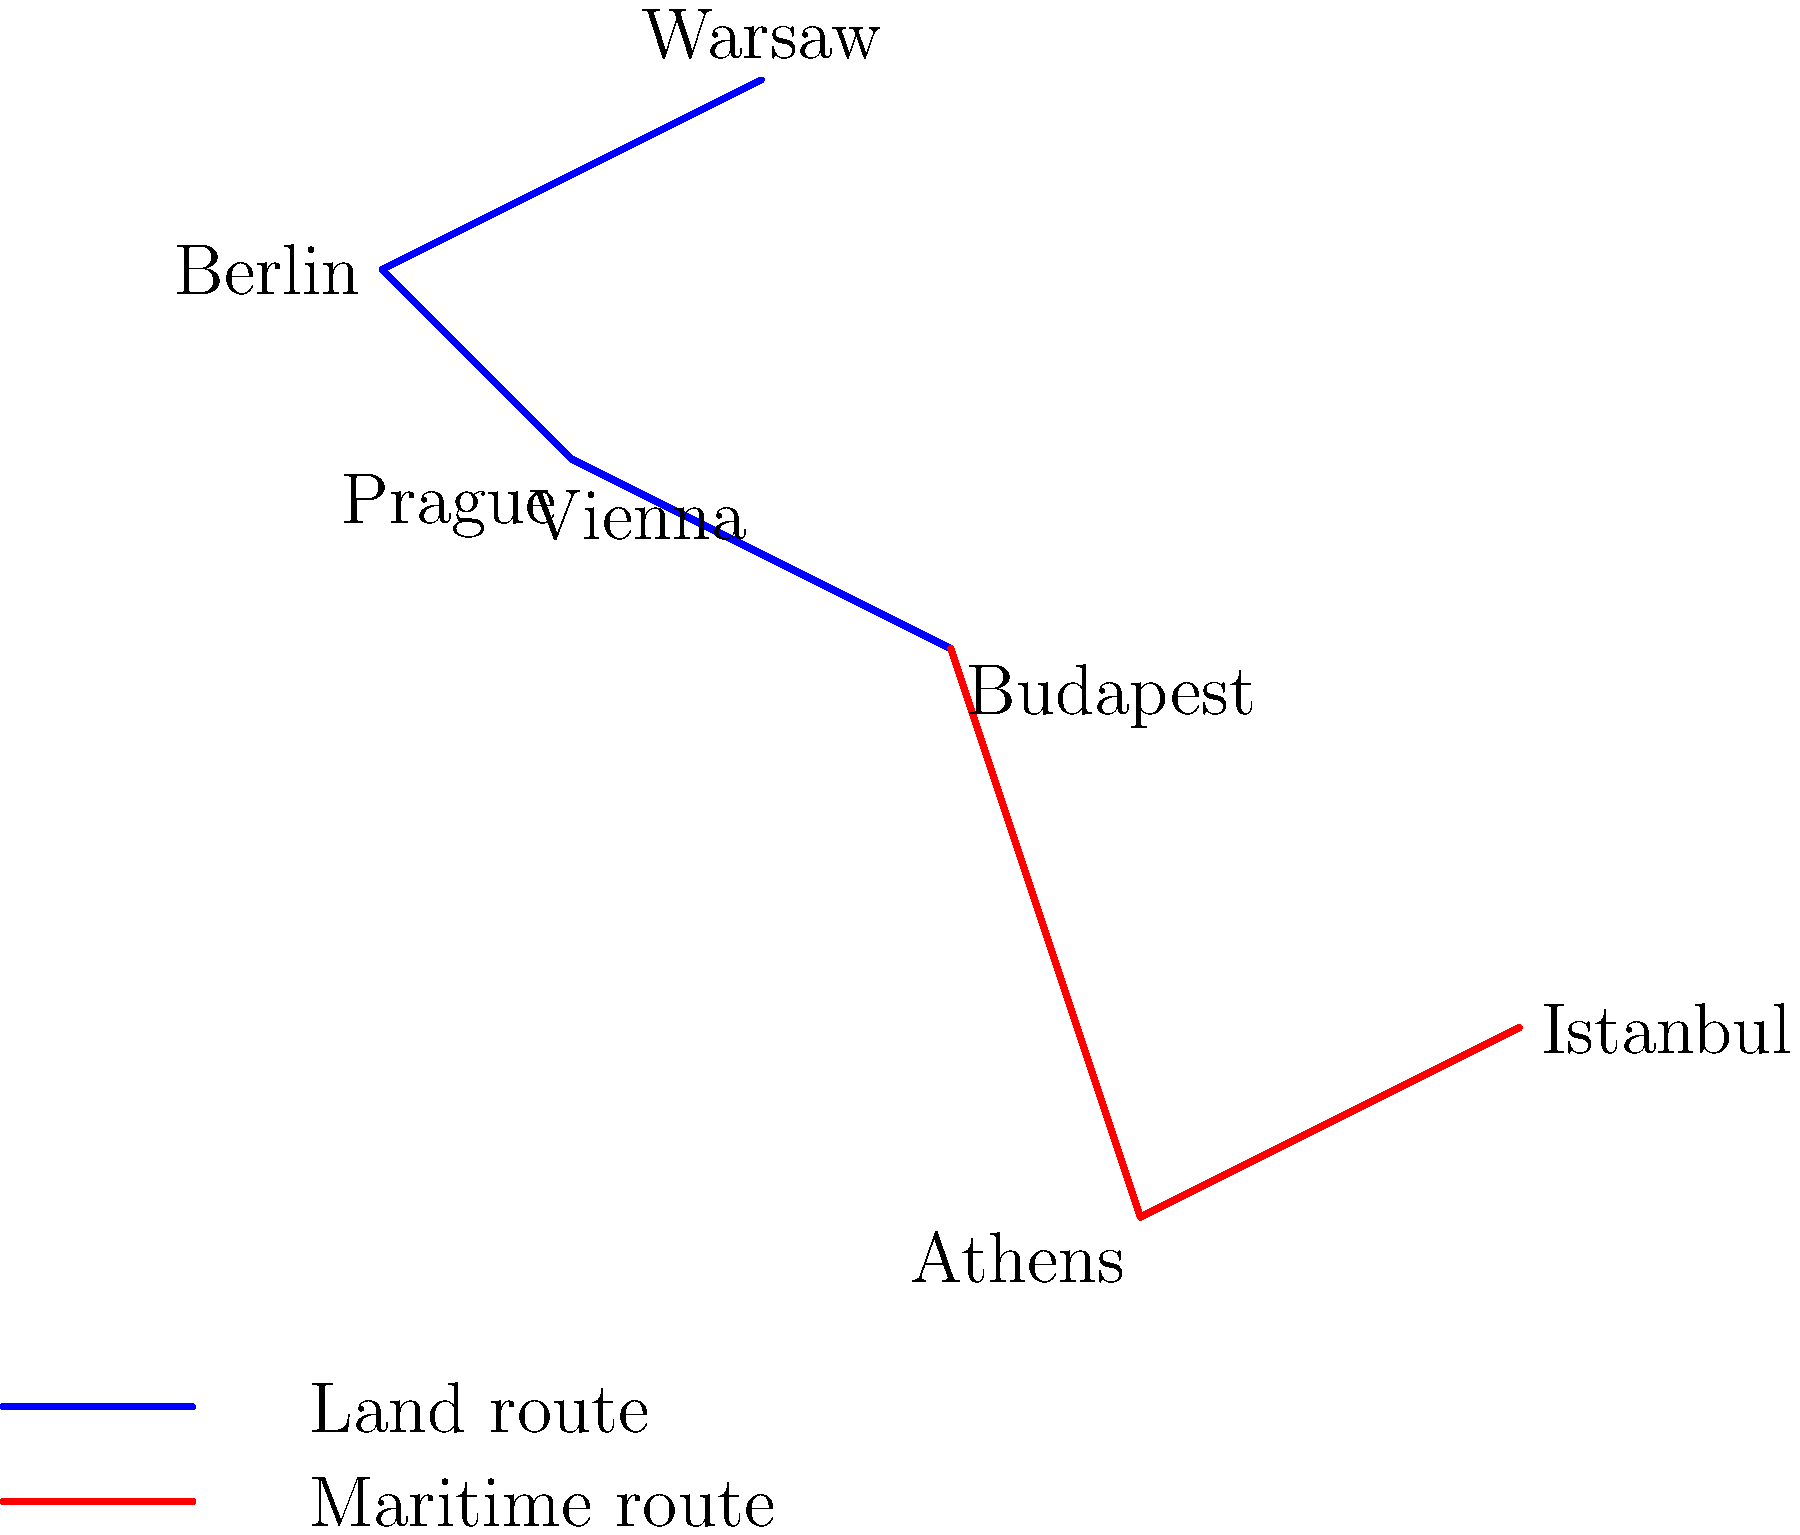Based on the map showing proposed Belt and Road Initiative (BRI) routes in Europe, which city serves as a crucial junction connecting the land route from Central Europe to the maritime route towards the Mediterranean and Black Sea regions? To answer this question, let's analyze the map step-by-step:

1. Observe the blue line representing the land route:
   - It connects Warsaw, Berlin, Prague, Vienna, and Budapest
   - This forms the main Central European corridor of the BRI

2. Notice the red line representing the maritime route:
   - It starts from Budapest and continues to Athens and Istanbul
   - This route connects Central Europe to the Mediterranean and Black Sea

3. Identify the junction point:
   - Budapest is the city where the blue line (land route) ends
   - Budapest is also where the red line (maritime route) begins

4. Understand the strategic importance:
   - Budapest acts as a transition point between the land-based Central European network and the maritime route to Southern Europe and Turkey
   - This position makes Budapest a crucial logistics and transportation hub for the BRI in Europe

5. Consider the implications for investors:
   - Budapest's role as a junction city could lead to increased infrastructure development and economic opportunities
   - Projects related to intermodal transportation, logistics centers, and trade facilitation in Budapest may be of particular interest to BRI investors
Answer: Budapest 